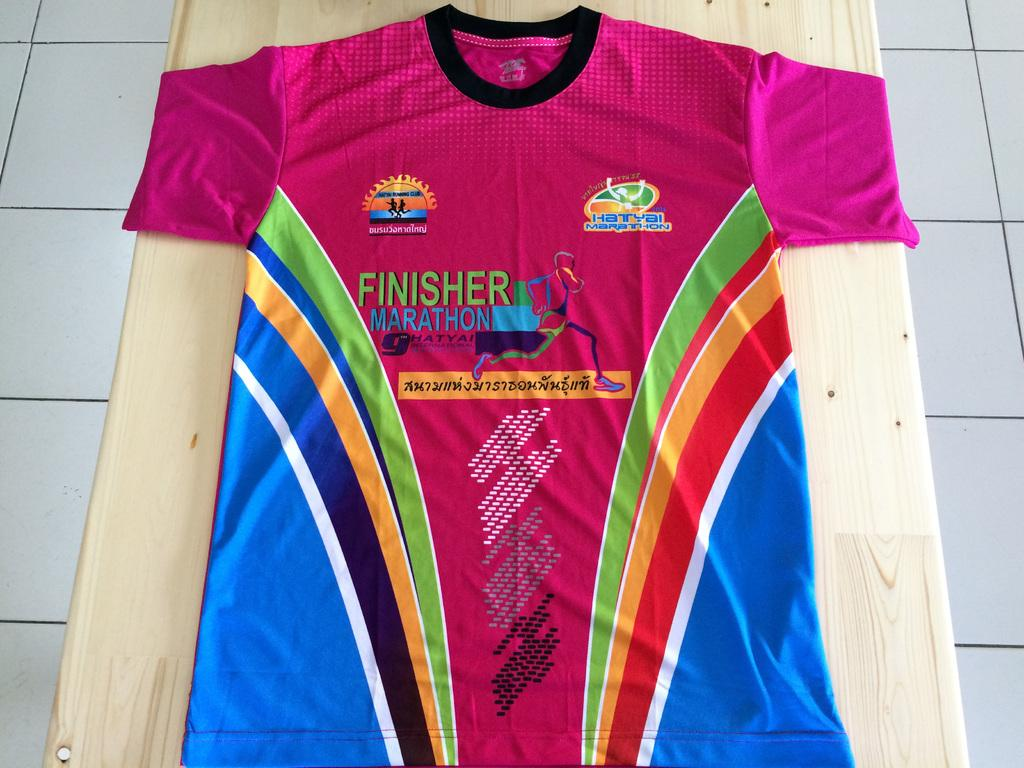Provide a one-sentence caption for the provided image. A marathon finisher's t-shirt lies on a wooden surface. 